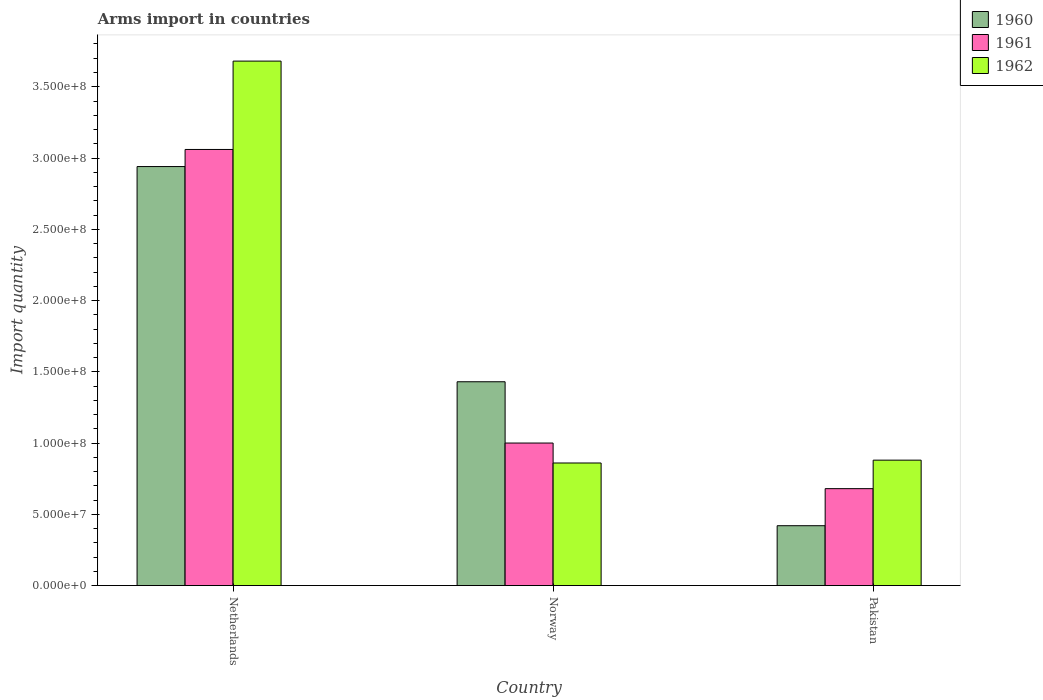Are the number of bars per tick equal to the number of legend labels?
Make the answer very short. Yes. How many bars are there on the 1st tick from the right?
Keep it short and to the point. 3. What is the label of the 1st group of bars from the left?
Offer a very short reply. Netherlands. Across all countries, what is the maximum total arms import in 1962?
Offer a very short reply. 3.68e+08. Across all countries, what is the minimum total arms import in 1961?
Ensure brevity in your answer.  6.80e+07. In which country was the total arms import in 1962 maximum?
Your answer should be compact. Netherlands. In which country was the total arms import in 1960 minimum?
Your response must be concise. Pakistan. What is the total total arms import in 1962 in the graph?
Ensure brevity in your answer.  5.42e+08. What is the difference between the total arms import in 1962 in Netherlands and that in Norway?
Your answer should be very brief. 2.82e+08. What is the difference between the total arms import in 1960 in Netherlands and the total arms import in 1962 in Pakistan?
Ensure brevity in your answer.  2.06e+08. What is the average total arms import in 1960 per country?
Keep it short and to the point. 1.60e+08. What is the difference between the total arms import of/in 1960 and total arms import of/in 1962 in Pakistan?
Your answer should be very brief. -4.60e+07. Is the total arms import in 1961 in Netherlands less than that in Norway?
Provide a short and direct response. No. Is the difference between the total arms import in 1960 in Netherlands and Norway greater than the difference between the total arms import in 1962 in Netherlands and Norway?
Give a very brief answer. No. What is the difference between the highest and the second highest total arms import in 1962?
Offer a very short reply. 2.80e+08. What is the difference between the highest and the lowest total arms import in 1962?
Offer a very short reply. 2.82e+08. Is the sum of the total arms import in 1962 in Netherlands and Pakistan greater than the maximum total arms import in 1960 across all countries?
Give a very brief answer. Yes. What does the 2nd bar from the right in Norway represents?
Provide a succinct answer. 1961. How many countries are there in the graph?
Provide a short and direct response. 3. What is the difference between two consecutive major ticks on the Y-axis?
Provide a succinct answer. 5.00e+07. Are the values on the major ticks of Y-axis written in scientific E-notation?
Provide a short and direct response. Yes. Does the graph contain any zero values?
Give a very brief answer. No. Does the graph contain grids?
Make the answer very short. No. How many legend labels are there?
Make the answer very short. 3. How are the legend labels stacked?
Your response must be concise. Vertical. What is the title of the graph?
Provide a short and direct response. Arms import in countries. What is the label or title of the X-axis?
Your answer should be very brief. Country. What is the label or title of the Y-axis?
Ensure brevity in your answer.  Import quantity. What is the Import quantity in 1960 in Netherlands?
Your answer should be compact. 2.94e+08. What is the Import quantity in 1961 in Netherlands?
Your answer should be very brief. 3.06e+08. What is the Import quantity of 1962 in Netherlands?
Your answer should be very brief. 3.68e+08. What is the Import quantity of 1960 in Norway?
Your answer should be compact. 1.43e+08. What is the Import quantity in 1962 in Norway?
Your response must be concise. 8.60e+07. What is the Import quantity of 1960 in Pakistan?
Your answer should be compact. 4.20e+07. What is the Import quantity in 1961 in Pakistan?
Keep it short and to the point. 6.80e+07. What is the Import quantity of 1962 in Pakistan?
Offer a very short reply. 8.80e+07. Across all countries, what is the maximum Import quantity in 1960?
Provide a short and direct response. 2.94e+08. Across all countries, what is the maximum Import quantity in 1961?
Provide a succinct answer. 3.06e+08. Across all countries, what is the maximum Import quantity in 1962?
Keep it short and to the point. 3.68e+08. Across all countries, what is the minimum Import quantity of 1960?
Your answer should be very brief. 4.20e+07. Across all countries, what is the minimum Import quantity of 1961?
Make the answer very short. 6.80e+07. Across all countries, what is the minimum Import quantity in 1962?
Provide a succinct answer. 8.60e+07. What is the total Import quantity of 1960 in the graph?
Offer a terse response. 4.79e+08. What is the total Import quantity in 1961 in the graph?
Keep it short and to the point. 4.74e+08. What is the total Import quantity in 1962 in the graph?
Offer a very short reply. 5.42e+08. What is the difference between the Import quantity in 1960 in Netherlands and that in Norway?
Offer a terse response. 1.51e+08. What is the difference between the Import quantity in 1961 in Netherlands and that in Norway?
Offer a very short reply. 2.06e+08. What is the difference between the Import quantity in 1962 in Netherlands and that in Norway?
Your response must be concise. 2.82e+08. What is the difference between the Import quantity of 1960 in Netherlands and that in Pakistan?
Provide a succinct answer. 2.52e+08. What is the difference between the Import quantity in 1961 in Netherlands and that in Pakistan?
Your response must be concise. 2.38e+08. What is the difference between the Import quantity in 1962 in Netherlands and that in Pakistan?
Your answer should be very brief. 2.80e+08. What is the difference between the Import quantity of 1960 in Norway and that in Pakistan?
Your answer should be very brief. 1.01e+08. What is the difference between the Import quantity of 1961 in Norway and that in Pakistan?
Offer a very short reply. 3.20e+07. What is the difference between the Import quantity of 1960 in Netherlands and the Import quantity of 1961 in Norway?
Your answer should be compact. 1.94e+08. What is the difference between the Import quantity of 1960 in Netherlands and the Import quantity of 1962 in Norway?
Keep it short and to the point. 2.08e+08. What is the difference between the Import quantity of 1961 in Netherlands and the Import quantity of 1962 in Norway?
Your response must be concise. 2.20e+08. What is the difference between the Import quantity of 1960 in Netherlands and the Import quantity of 1961 in Pakistan?
Make the answer very short. 2.26e+08. What is the difference between the Import quantity in 1960 in Netherlands and the Import quantity in 1962 in Pakistan?
Your response must be concise. 2.06e+08. What is the difference between the Import quantity in 1961 in Netherlands and the Import quantity in 1962 in Pakistan?
Your response must be concise. 2.18e+08. What is the difference between the Import quantity of 1960 in Norway and the Import quantity of 1961 in Pakistan?
Provide a short and direct response. 7.50e+07. What is the difference between the Import quantity in 1960 in Norway and the Import quantity in 1962 in Pakistan?
Provide a succinct answer. 5.50e+07. What is the average Import quantity of 1960 per country?
Keep it short and to the point. 1.60e+08. What is the average Import quantity in 1961 per country?
Your answer should be compact. 1.58e+08. What is the average Import quantity of 1962 per country?
Your answer should be very brief. 1.81e+08. What is the difference between the Import quantity of 1960 and Import quantity of 1961 in Netherlands?
Provide a short and direct response. -1.20e+07. What is the difference between the Import quantity in 1960 and Import quantity in 1962 in Netherlands?
Provide a short and direct response. -7.40e+07. What is the difference between the Import quantity of 1961 and Import quantity of 1962 in Netherlands?
Make the answer very short. -6.20e+07. What is the difference between the Import quantity in 1960 and Import quantity in 1961 in Norway?
Your response must be concise. 4.30e+07. What is the difference between the Import quantity of 1960 and Import quantity of 1962 in Norway?
Your answer should be very brief. 5.70e+07. What is the difference between the Import quantity in 1961 and Import quantity in 1962 in Norway?
Your answer should be compact. 1.40e+07. What is the difference between the Import quantity in 1960 and Import quantity in 1961 in Pakistan?
Ensure brevity in your answer.  -2.60e+07. What is the difference between the Import quantity in 1960 and Import quantity in 1962 in Pakistan?
Keep it short and to the point. -4.60e+07. What is the difference between the Import quantity of 1961 and Import quantity of 1962 in Pakistan?
Ensure brevity in your answer.  -2.00e+07. What is the ratio of the Import quantity of 1960 in Netherlands to that in Norway?
Your answer should be very brief. 2.06. What is the ratio of the Import quantity in 1961 in Netherlands to that in Norway?
Offer a very short reply. 3.06. What is the ratio of the Import quantity of 1962 in Netherlands to that in Norway?
Provide a short and direct response. 4.28. What is the ratio of the Import quantity of 1962 in Netherlands to that in Pakistan?
Your answer should be compact. 4.18. What is the ratio of the Import quantity of 1960 in Norway to that in Pakistan?
Offer a very short reply. 3.4. What is the ratio of the Import quantity in 1961 in Norway to that in Pakistan?
Your answer should be very brief. 1.47. What is the ratio of the Import quantity of 1962 in Norway to that in Pakistan?
Provide a short and direct response. 0.98. What is the difference between the highest and the second highest Import quantity of 1960?
Your response must be concise. 1.51e+08. What is the difference between the highest and the second highest Import quantity in 1961?
Your answer should be compact. 2.06e+08. What is the difference between the highest and the second highest Import quantity in 1962?
Provide a succinct answer. 2.80e+08. What is the difference between the highest and the lowest Import quantity in 1960?
Provide a short and direct response. 2.52e+08. What is the difference between the highest and the lowest Import quantity of 1961?
Offer a terse response. 2.38e+08. What is the difference between the highest and the lowest Import quantity in 1962?
Make the answer very short. 2.82e+08. 